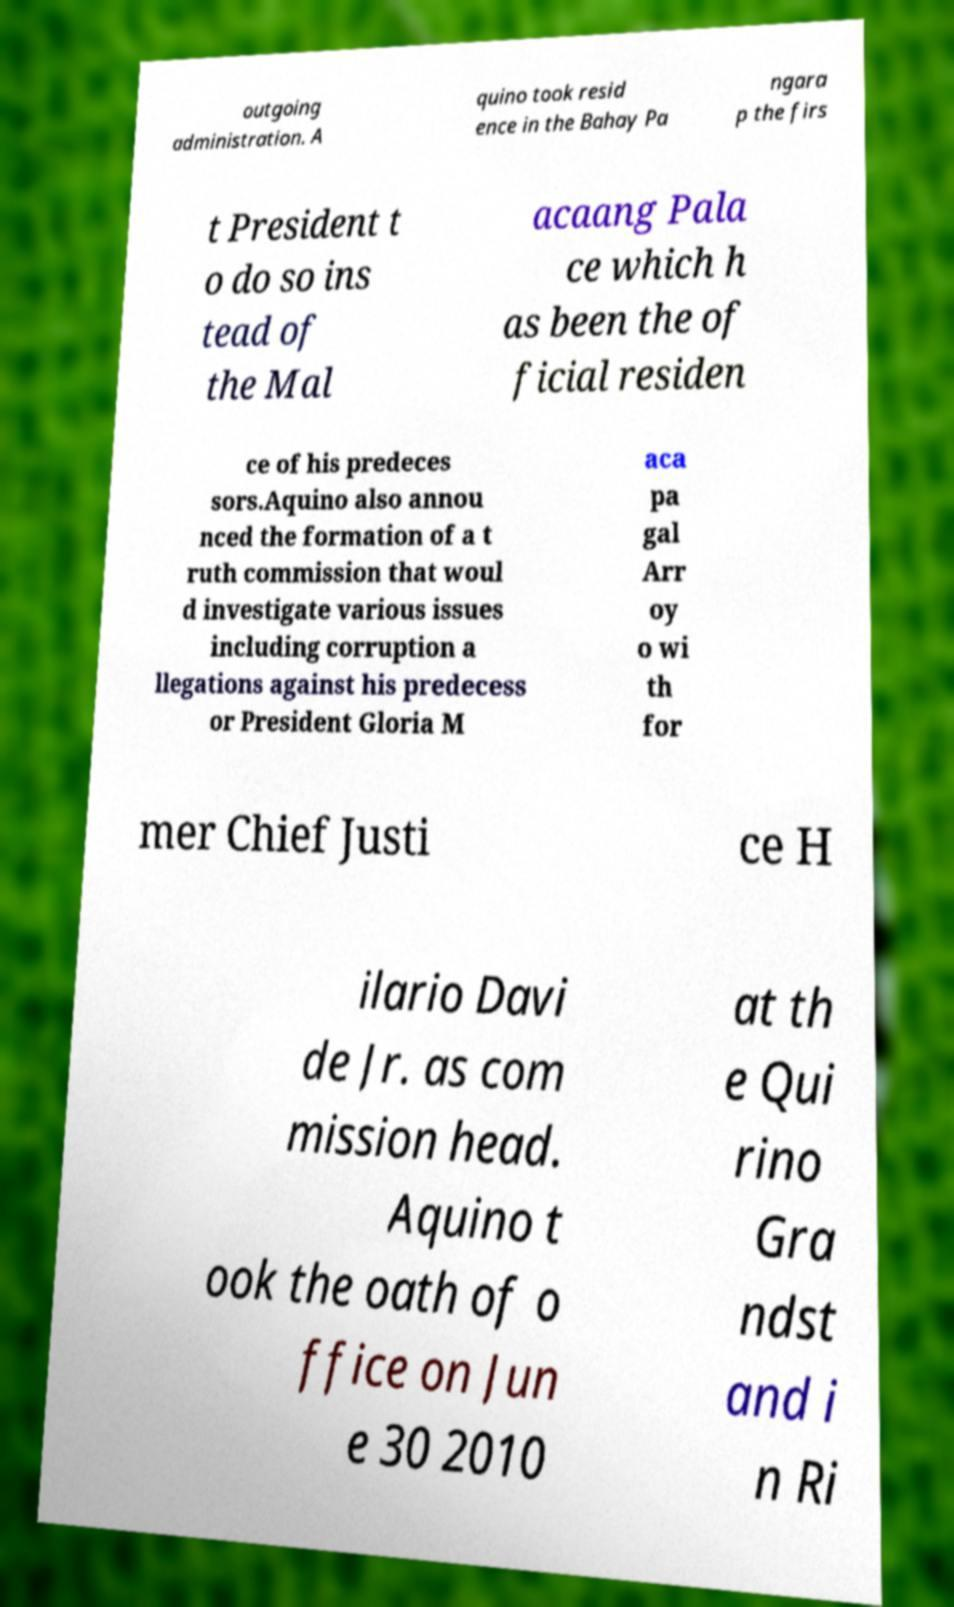Can you accurately transcribe the text from the provided image for me? outgoing administration. A quino took resid ence in the Bahay Pa ngara p the firs t President t o do so ins tead of the Mal acaang Pala ce which h as been the of ficial residen ce of his predeces sors.Aquino also annou nced the formation of a t ruth commission that woul d investigate various issues including corruption a llegations against his predecess or President Gloria M aca pa gal Arr oy o wi th for mer Chief Justi ce H ilario Davi de Jr. as com mission head. Aquino t ook the oath of o ffice on Jun e 30 2010 at th e Qui rino Gra ndst and i n Ri 